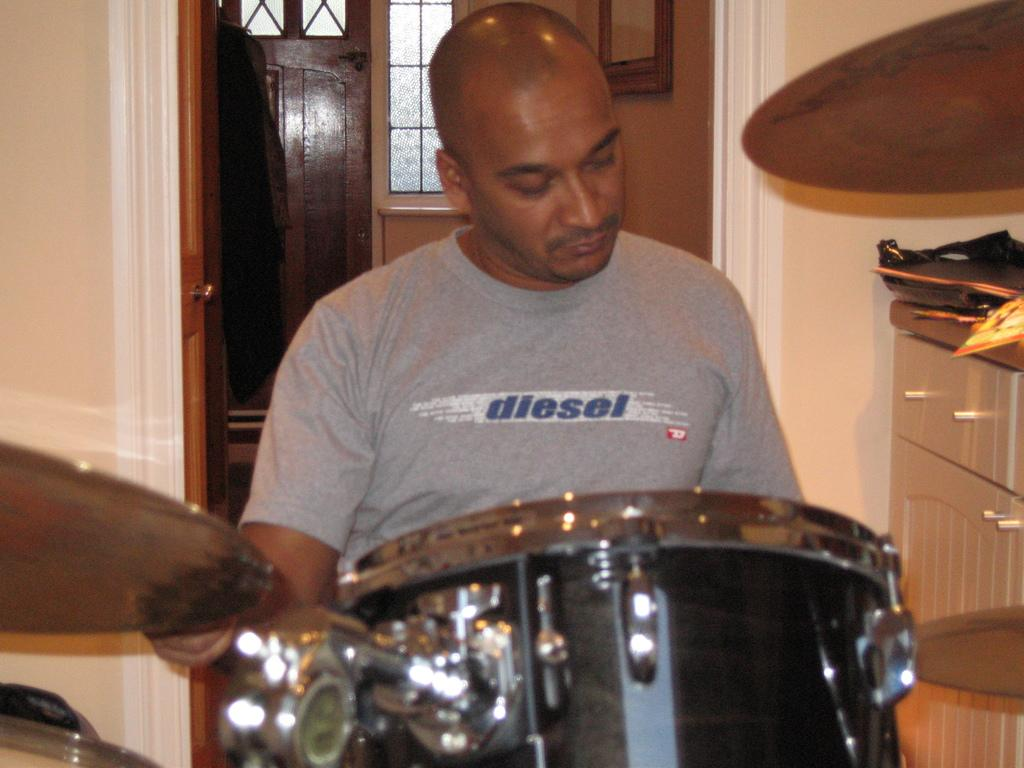Who or what is the main subject in the image? There is a person in the image. What is the person wearing? The person is wearing a gray t-shirt. What can be seen behind the person? There is a door behind the person. What is in front of the person? There is a musical instrument in front of the person. What type of locket is the person holding in the image? There is no locket present in the image. What color is the person's underwear in the image? The image does not show the person's underwear, so it cannot be determined from the image. 